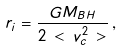Convert formula to latex. <formula><loc_0><loc_0><loc_500><loc_500>r _ { i } = \frac { G M _ { B H } } { 2 \, < \, v _ { c } ^ { 2 } \, > } \, ,</formula> 